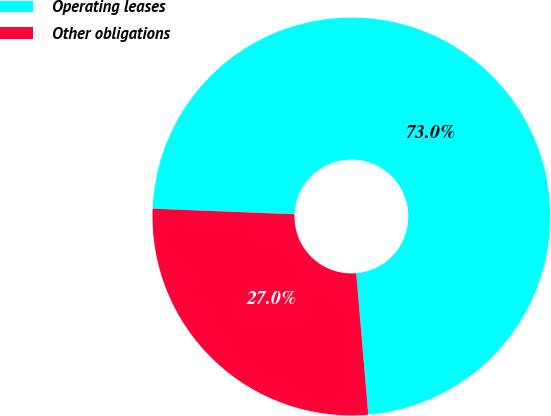Convert chart. <chart><loc_0><loc_0><loc_500><loc_500><pie_chart><fcel>Operating leases<fcel>Other obligations<nl><fcel>73.02%<fcel>26.98%<nl></chart> 